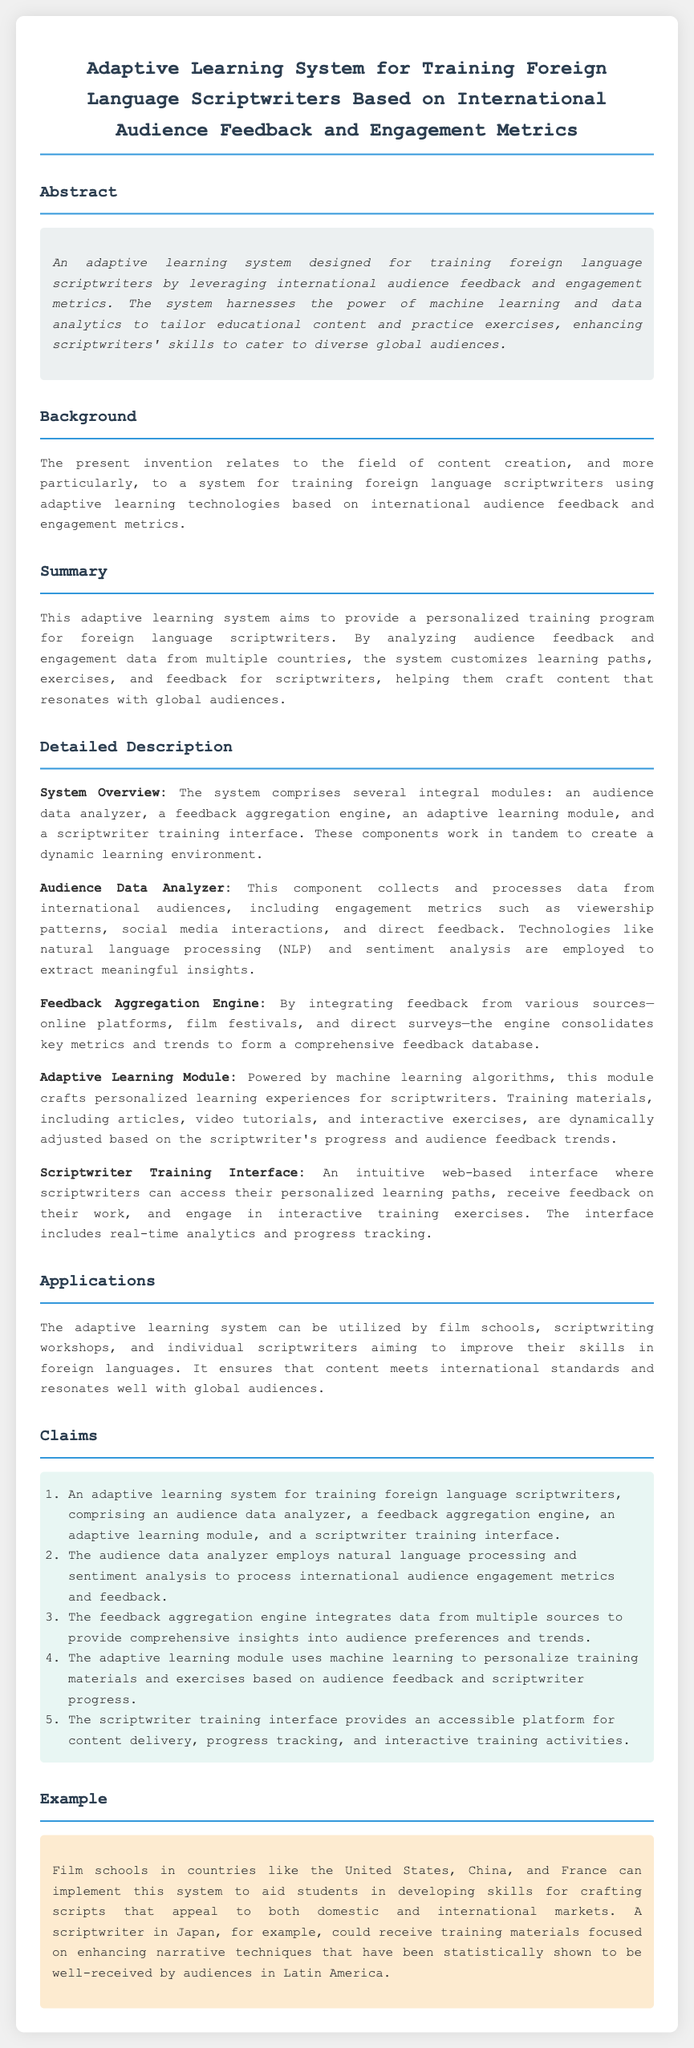What is the title of the patent? The title is a key element of the document that summarizes the invention.
Answer: Adaptive Learning System for Training Foreign Language Scriptwriters Based on International Audience Feedback and Engagement Metrics What is the main purpose of the adaptive learning system? The purpose outlines the function or goal of the invention as stated in the document.
Answer: To leverage international audience feedback and engagement metrics for training scriptwriters Which technologies does the Audience Data Analyzer use? This question focuses on specific technologies mentioned in the descriptions of the system components.
Answer: Natural language processing and sentiment analysis What are the four main components of the system? The question aims to identify the integral parts of the adaptive learning system from the claims section.
Answer: Audience data analyzer, feedback aggregation engine, adaptive learning module, scriptwriter training interface How does the adaptive learning module personalize training? This question requires synthesis of information regarding how user experience is tailored.
Answer: By using machine learning algorithms based on audience feedback and scriptwriter progress In what context can the system be implemented? This question seeks to establish the practical applications of the system as stated in the document.
Answer: Film schools, scriptwriting workshops, individual scriptwriters What type of interface does the scriptwriter training module provide? The question targets the specific nature of the interface as described in the detailed description.
Answer: Web-based interface What international market example is given in the document? The answer to this question pertains to a specific example cited to illustrate application.
Answer: Japan How does the feedback aggregation engine operate? The question seeks to examine the functionality of a particular component in the system.
Answer: It consolidates key metrics and trends to form a comprehensive feedback database 